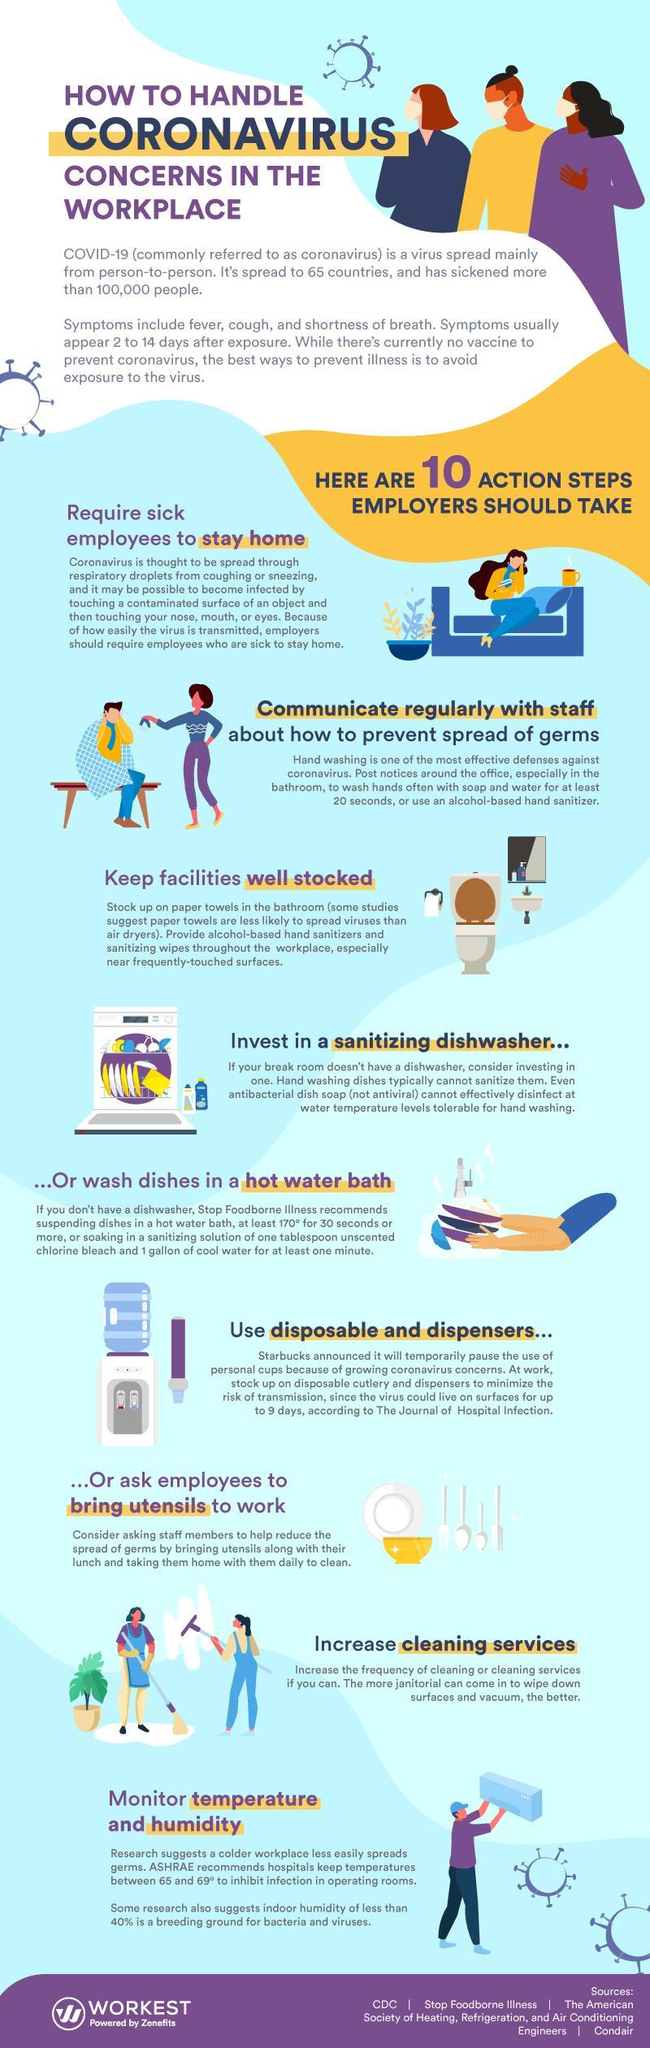How many people are shown in the infographic?
Answer the question with a short phrase. 9 What is the colour of the bowl shown- yellow, blue or red? yellow 